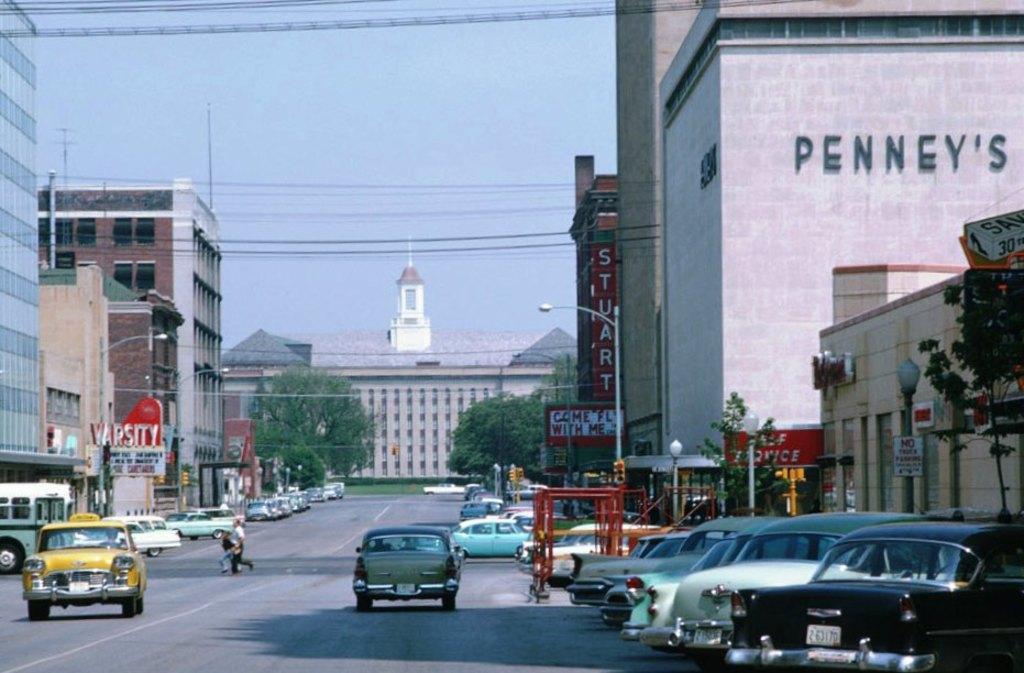<image>
Give a short and clear explanation of the subsequent image. A large Penny's shop can be seen in a busy street. 